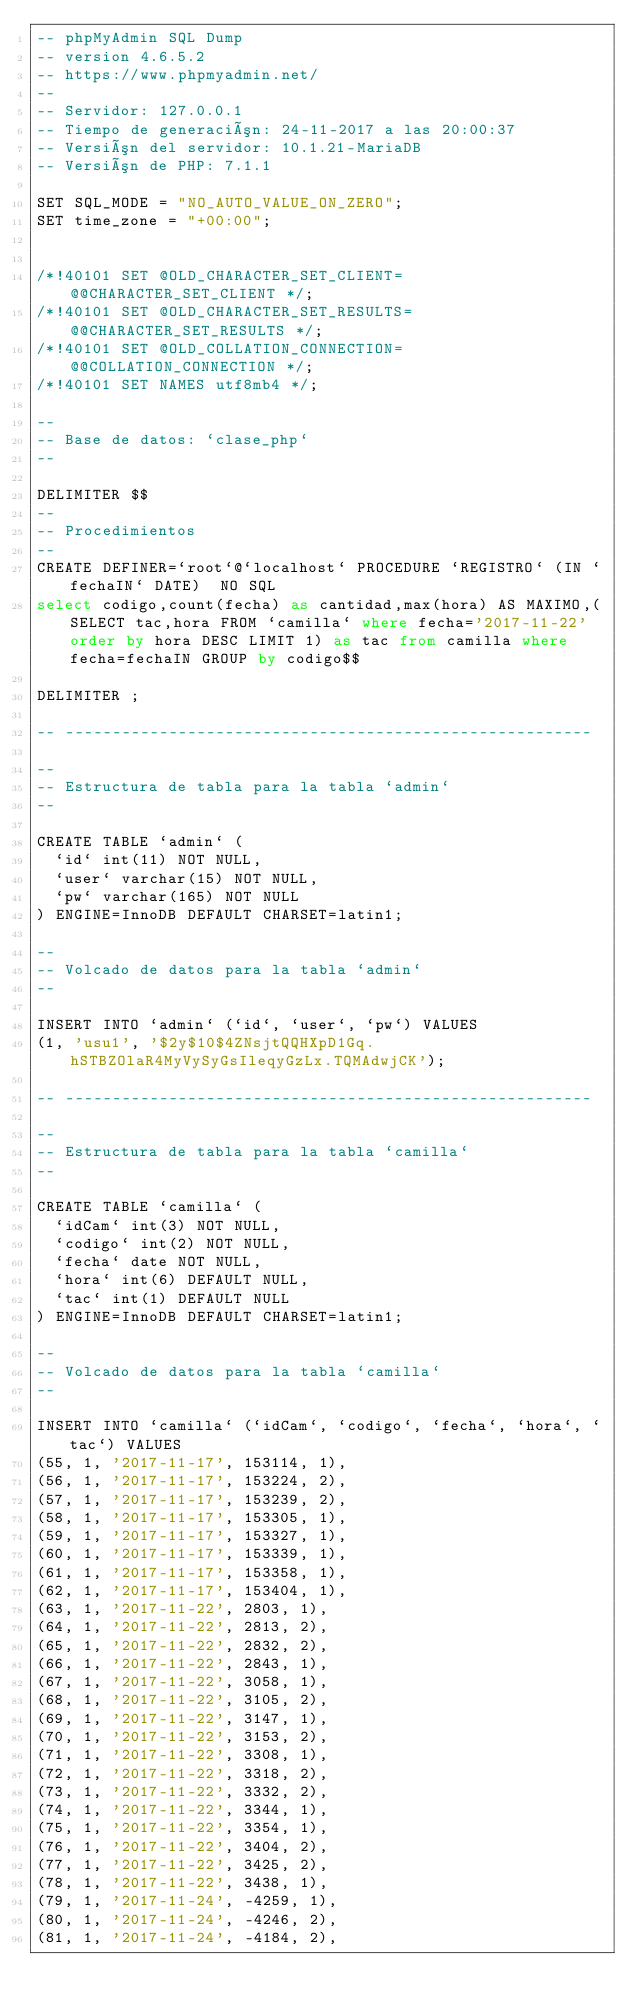Convert code to text. <code><loc_0><loc_0><loc_500><loc_500><_SQL_>-- phpMyAdmin SQL Dump
-- version 4.6.5.2
-- https://www.phpmyadmin.net/
--
-- Servidor: 127.0.0.1
-- Tiempo de generación: 24-11-2017 a las 20:00:37
-- Versión del servidor: 10.1.21-MariaDB
-- Versión de PHP: 7.1.1

SET SQL_MODE = "NO_AUTO_VALUE_ON_ZERO";
SET time_zone = "+00:00";


/*!40101 SET @OLD_CHARACTER_SET_CLIENT=@@CHARACTER_SET_CLIENT */;
/*!40101 SET @OLD_CHARACTER_SET_RESULTS=@@CHARACTER_SET_RESULTS */;
/*!40101 SET @OLD_COLLATION_CONNECTION=@@COLLATION_CONNECTION */;
/*!40101 SET NAMES utf8mb4 */;

--
-- Base de datos: `clase_php`
--

DELIMITER $$
--
-- Procedimientos
--
CREATE DEFINER=`root`@`localhost` PROCEDURE `REGISTRO` (IN `fechaIN` DATE)  NO SQL
select codigo,count(fecha) as cantidad,max(hora) AS MAXIMO,(SELECT tac,hora FROM `camilla` where fecha='2017-11-22' order by hora DESC LIMIT 1) as tac from camilla where fecha=fechaIN GROUP by codigo$$

DELIMITER ;

-- --------------------------------------------------------

--
-- Estructura de tabla para la tabla `admin`
--

CREATE TABLE `admin` (
  `id` int(11) NOT NULL,
  `user` varchar(15) NOT NULL,
  `pw` varchar(165) NOT NULL
) ENGINE=InnoDB DEFAULT CHARSET=latin1;

--
-- Volcado de datos para la tabla `admin`
--

INSERT INTO `admin` (`id`, `user`, `pw`) VALUES
(1, 'usu1', '$2y$10$4ZNsjtQQHXpD1Gq.hSTBZOlaR4MyVySyGsIleqyGzLx.TQMAdwjCK');

-- --------------------------------------------------------

--
-- Estructura de tabla para la tabla `camilla`
--

CREATE TABLE `camilla` (
  `idCam` int(3) NOT NULL,
  `codigo` int(2) NOT NULL,
  `fecha` date NOT NULL,
  `hora` int(6) DEFAULT NULL,
  `tac` int(1) DEFAULT NULL
) ENGINE=InnoDB DEFAULT CHARSET=latin1;

--
-- Volcado de datos para la tabla `camilla`
--

INSERT INTO `camilla` (`idCam`, `codigo`, `fecha`, `hora`, `tac`) VALUES
(55, 1, '2017-11-17', 153114, 1),
(56, 1, '2017-11-17', 153224, 2),
(57, 1, '2017-11-17', 153239, 2),
(58, 1, '2017-11-17', 153305, 1),
(59, 1, '2017-11-17', 153327, 1),
(60, 1, '2017-11-17', 153339, 1),
(61, 1, '2017-11-17', 153358, 1),
(62, 1, '2017-11-17', 153404, 1),
(63, 1, '2017-11-22', 2803, 1),
(64, 1, '2017-11-22', 2813, 2),
(65, 1, '2017-11-22', 2832, 2),
(66, 1, '2017-11-22', 2843, 1),
(67, 1, '2017-11-22', 3058, 1),
(68, 1, '2017-11-22', 3105, 2),
(69, 1, '2017-11-22', 3147, 1),
(70, 1, '2017-11-22', 3153, 2),
(71, 1, '2017-11-22', 3308, 1),
(72, 1, '2017-11-22', 3318, 2),
(73, 1, '2017-11-22', 3332, 2),
(74, 1, '2017-11-22', 3344, 1),
(75, 1, '2017-11-22', 3354, 1),
(76, 1, '2017-11-22', 3404, 2),
(77, 1, '2017-11-22', 3425, 2),
(78, 1, '2017-11-22', 3438, 1),
(79, 1, '2017-11-24', -4259, 1),
(80, 1, '2017-11-24', -4246, 2),
(81, 1, '2017-11-24', -4184, 2),</code> 